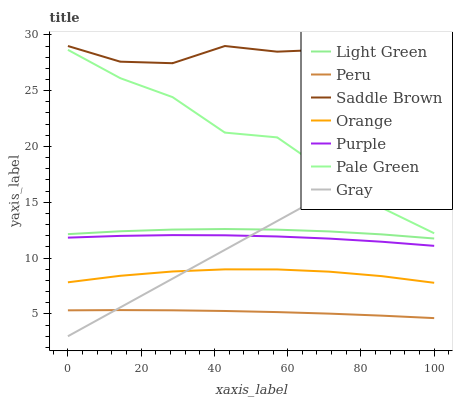Does Peru have the minimum area under the curve?
Answer yes or no. Yes. Does Saddle Brown have the maximum area under the curve?
Answer yes or no. Yes. Does Light Green have the minimum area under the curve?
Answer yes or no. No. Does Light Green have the maximum area under the curve?
Answer yes or no. No. Is Gray the smoothest?
Answer yes or no. Yes. Is Pale Green the roughest?
Answer yes or no. Yes. Is Light Green the smoothest?
Answer yes or no. No. Is Light Green the roughest?
Answer yes or no. No. Does Gray have the lowest value?
Answer yes or no. Yes. Does Light Green have the lowest value?
Answer yes or no. No. Does Saddle Brown have the highest value?
Answer yes or no. Yes. Does Light Green have the highest value?
Answer yes or no. No. Is Light Green less than Pale Green?
Answer yes or no. Yes. Is Pale Green greater than Peru?
Answer yes or no. Yes. Does Gray intersect Light Green?
Answer yes or no. Yes. Is Gray less than Light Green?
Answer yes or no. No. Is Gray greater than Light Green?
Answer yes or no. No. Does Light Green intersect Pale Green?
Answer yes or no. No. 